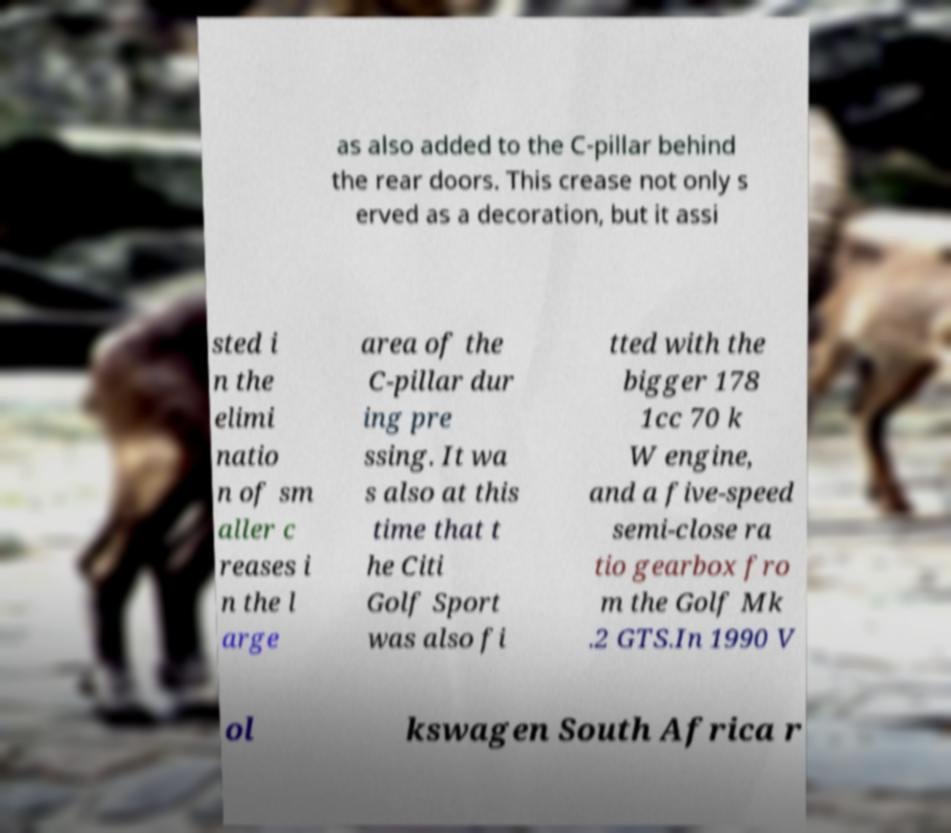Can you read and provide the text displayed in the image?This photo seems to have some interesting text. Can you extract and type it out for me? as also added to the C-pillar behind the rear doors. This crease not only s erved as a decoration, but it assi sted i n the elimi natio n of sm aller c reases i n the l arge area of the C-pillar dur ing pre ssing. It wa s also at this time that t he Citi Golf Sport was also fi tted with the bigger 178 1cc 70 k W engine, and a five-speed semi-close ra tio gearbox fro m the Golf Mk .2 GTS.In 1990 V ol kswagen South Africa r 